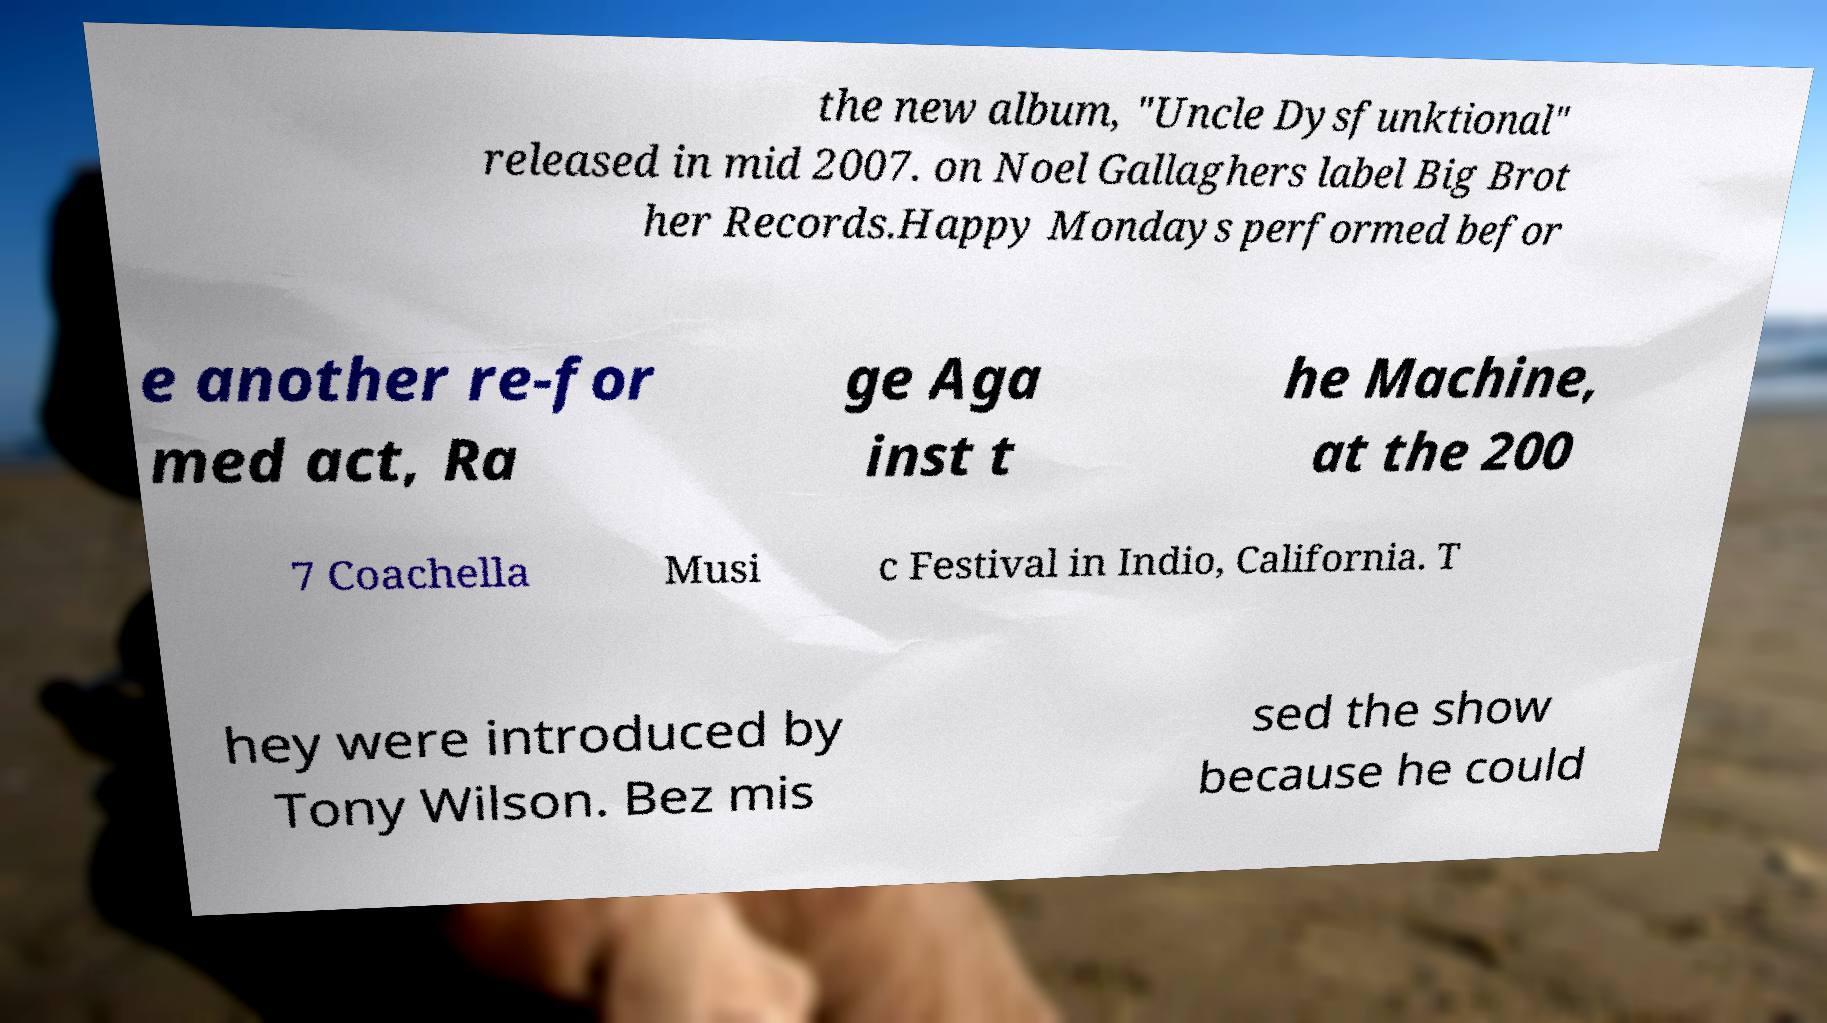For documentation purposes, I need the text within this image transcribed. Could you provide that? the new album, "Uncle Dysfunktional" released in mid 2007. on Noel Gallaghers label Big Brot her Records.Happy Mondays performed befor e another re-for med act, Ra ge Aga inst t he Machine, at the 200 7 Coachella Musi c Festival in Indio, California. T hey were introduced by Tony Wilson. Bez mis sed the show because he could 